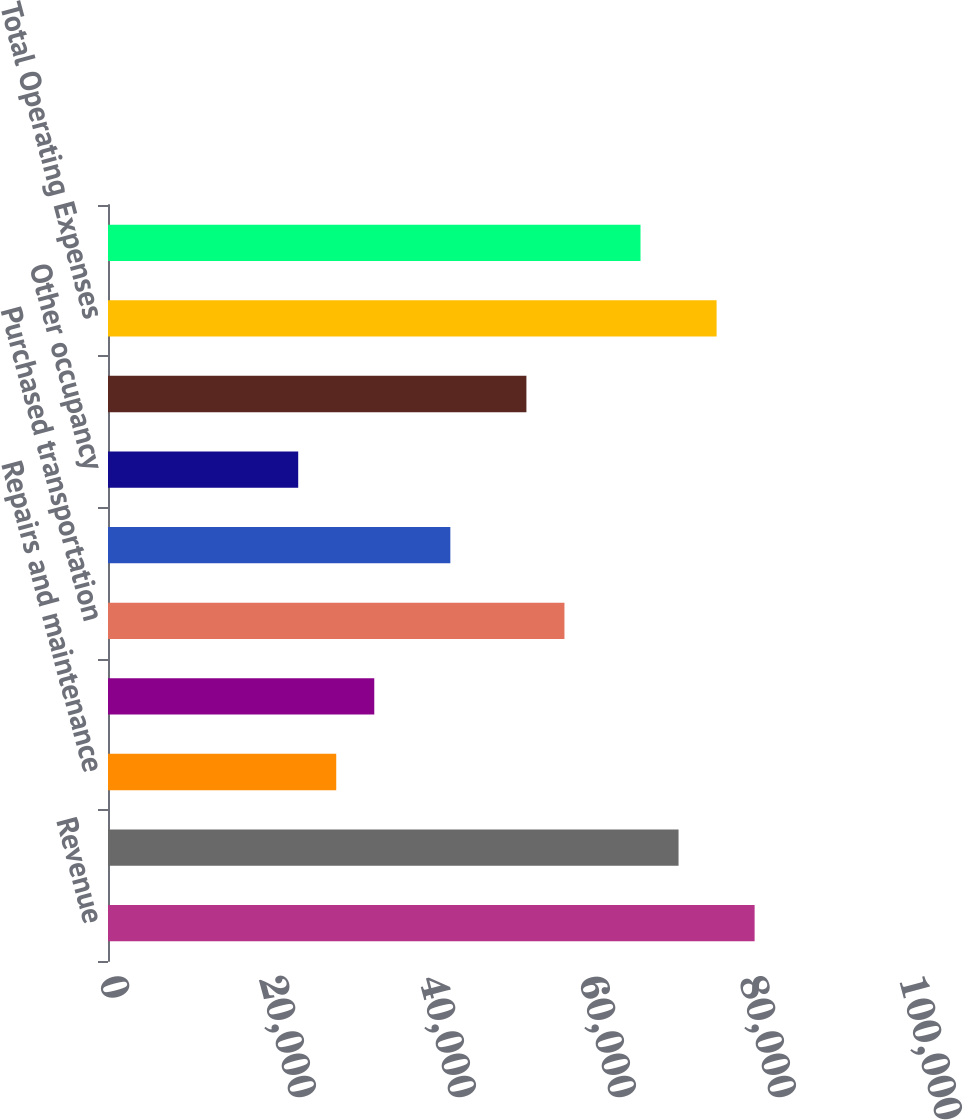<chart> <loc_0><loc_0><loc_500><loc_500><bar_chart><fcel>Revenue<fcel>Compensation and benefits<fcel>Repairs and maintenance<fcel>Depreciation and amortization<fcel>Purchased transportation<fcel>Fuel<fcel>Other occupancy<fcel>Other expenses<fcel>Total Operating Expenses<fcel>Operating Profit<nl><fcel>80827.1<fcel>71318.5<fcel>28529.7<fcel>33284<fcel>57055.6<fcel>42792.7<fcel>23775.4<fcel>52301.3<fcel>76072.8<fcel>66564.2<nl></chart> 